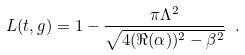<formula> <loc_0><loc_0><loc_500><loc_500>L ( t , g ) = 1 - \frac { \pi \Lambda ^ { 2 } } { \sqrt { 4 ( \Re ( \alpha ) ) ^ { 2 } - \beta ^ { 2 } } } \ .</formula> 